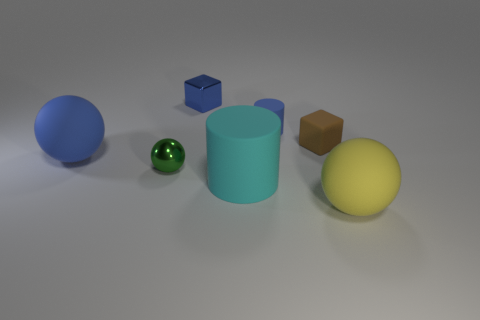There is a metal object that is right of the green shiny thing that is to the left of the rubber cylinder that is to the right of the big matte cylinder; what shape is it?
Your answer should be compact. Cube. Are there an equal number of small shiny spheres behind the small blue matte object and large blue matte spheres?
Offer a very short reply. No. There is a rubber cylinder that is the same color as the shiny cube; what size is it?
Keep it short and to the point. Small. Do the small brown thing and the large blue object have the same shape?
Offer a very short reply. No. What number of things are either big spheres on the left side of the big cyan cylinder or blue objects?
Your answer should be compact. 3. Is the number of blue cubes that are to the left of the green object the same as the number of small blue cubes that are in front of the big blue ball?
Provide a succinct answer. Yes. What number of other things are the same shape as the tiny blue rubber thing?
Give a very brief answer. 1. Do the cylinder that is in front of the big blue matte object and the blue rubber thing behind the big blue rubber object have the same size?
Ensure brevity in your answer.  No. How many balls are small green metal objects or big rubber things?
Provide a short and direct response. 3. What number of metal things are yellow balls or small cylinders?
Provide a succinct answer. 0. 